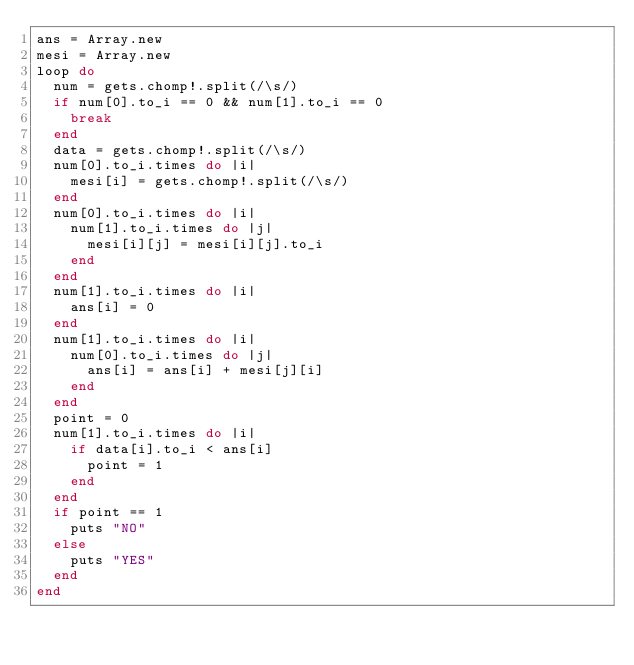<code> <loc_0><loc_0><loc_500><loc_500><_Ruby_>ans = Array.new
mesi = Array.new
loop do
  num = gets.chomp!.split(/\s/)
  if num[0].to_i == 0 && num[1].to_i == 0
    break
  end
  data = gets.chomp!.split(/\s/)
  num[0].to_i.times do |i|
    mesi[i] = gets.chomp!.split(/\s/)
  end
  num[0].to_i.times do |i|
    num[1].to_i.times do |j|
      mesi[i][j] = mesi[i][j].to_i
    end
  end
  num[1].to_i.times do |i|
    ans[i] = 0
  end
  num[1].to_i.times do |i|
    num[0].to_i.times do |j|
      ans[i] = ans[i] + mesi[j][i]
    end
  end
  point = 0
  num[1].to_i.times do |i|
    if data[i].to_i < ans[i]
      point = 1
    end
  end
  if point == 1
    puts "NO"
  else
    puts "YES"
  end
end</code> 